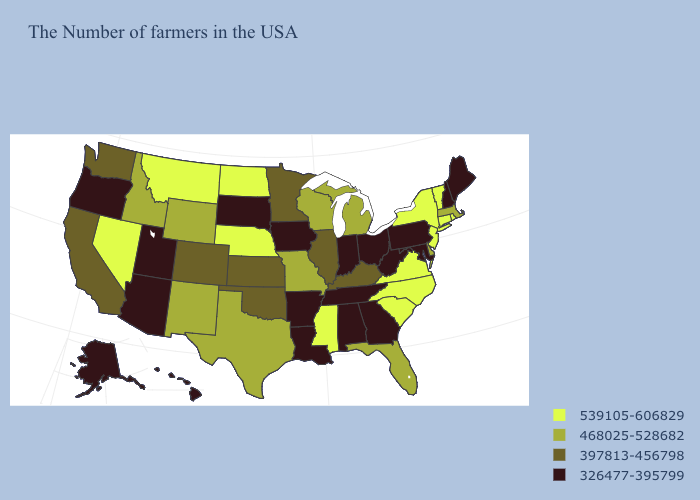Among the states that border Minnesota , which have the highest value?
Write a very short answer. North Dakota. Among the states that border Utah , which have the lowest value?
Keep it brief. Arizona. Among the states that border Wyoming , does Utah have the highest value?
Quick response, please. No. What is the highest value in states that border Michigan?
Concise answer only. 468025-528682. What is the value of Washington?
Short answer required. 397813-456798. Name the states that have a value in the range 539105-606829?
Write a very short answer. Rhode Island, Vermont, Connecticut, New York, New Jersey, Virginia, North Carolina, South Carolina, Mississippi, Nebraska, North Dakota, Montana, Nevada. Does New Hampshire have the highest value in the Northeast?
Short answer required. No. Does Ohio have the lowest value in the MidWest?
Be succinct. Yes. Among the states that border Kansas , does Oklahoma have the lowest value?
Keep it brief. Yes. What is the value of Washington?
Concise answer only. 397813-456798. What is the value of Wisconsin?
Concise answer only. 468025-528682. What is the value of Tennessee?
Concise answer only. 326477-395799. Is the legend a continuous bar?
Concise answer only. No. Among the states that border Vermont , which have the highest value?
Give a very brief answer. New York. Which states have the highest value in the USA?
Give a very brief answer. Rhode Island, Vermont, Connecticut, New York, New Jersey, Virginia, North Carolina, South Carolina, Mississippi, Nebraska, North Dakota, Montana, Nevada. 